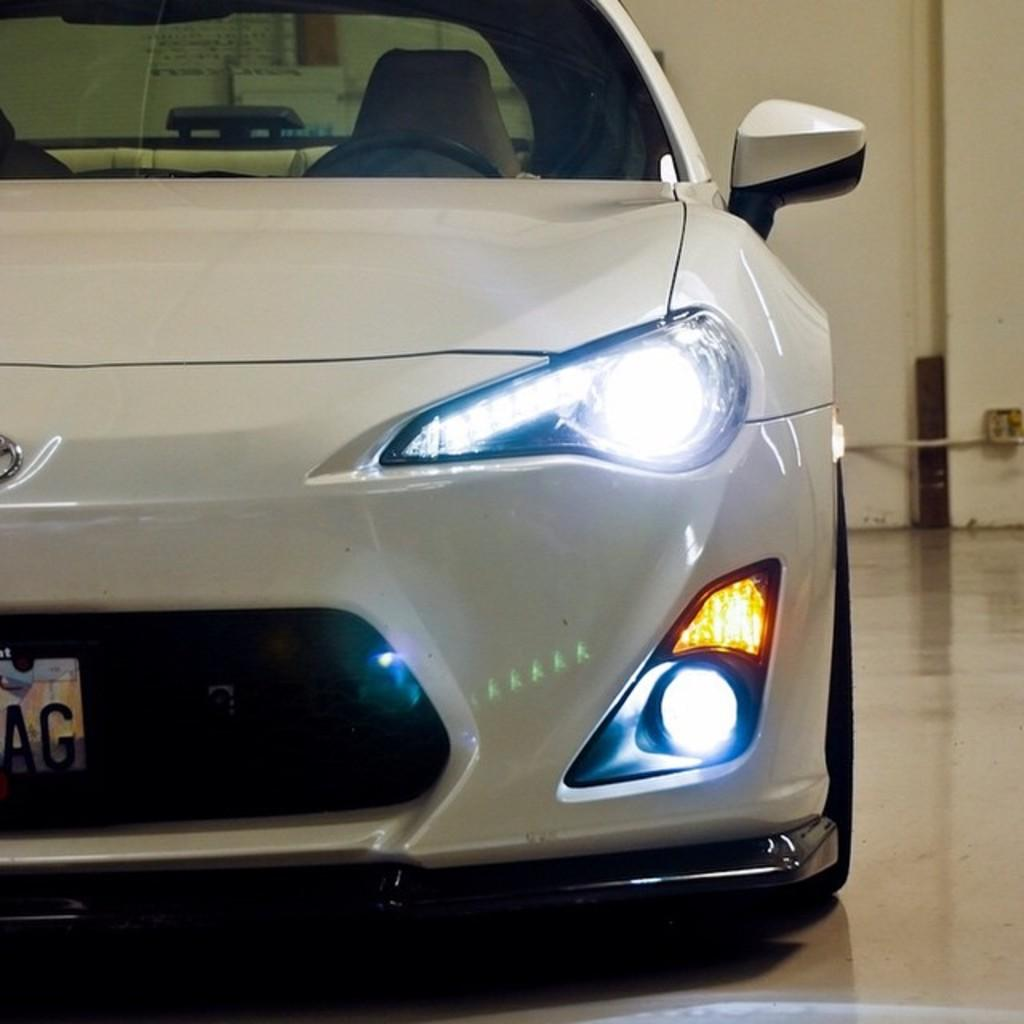What color is the car in the image? The car in the image is white. Where is the car located in the image? The car is in the front of the image. What can be seen in the background of the image? There is a wall in the background of the image. What features are visible on the car? There are lights and an indicator visible on the car. Can you see the grandmother holding a cork in the image? There is no grandmother or cork present in the image. What type of pump is visible near the car in the image? There is no pump visible in the image; it only features a white color car, a wall in the background, and visible features on the car. 